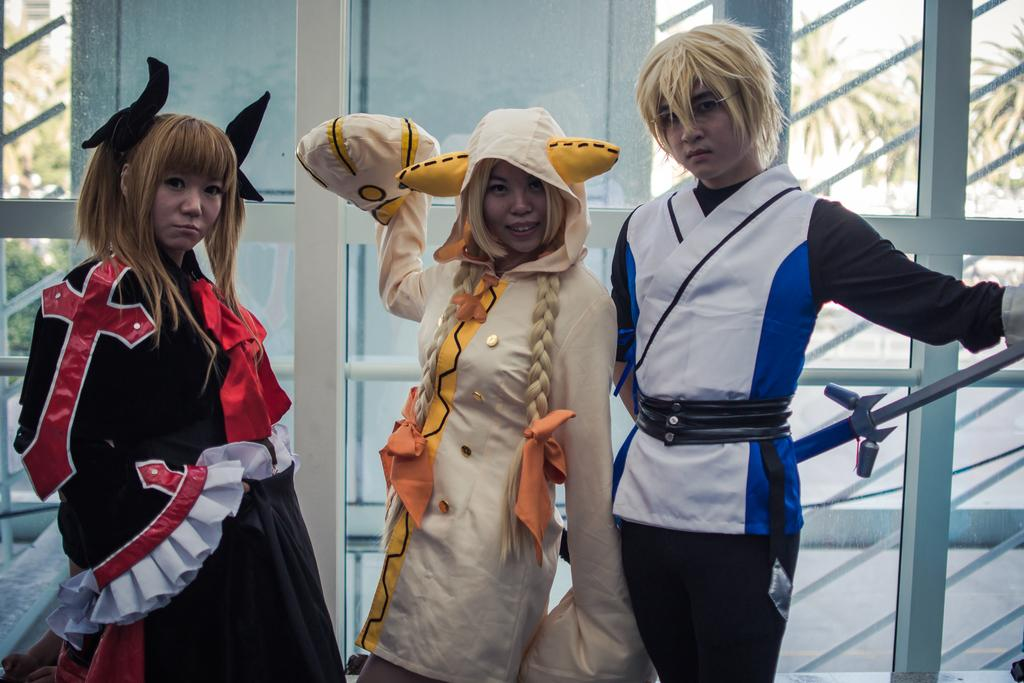How many people are in the image? There is a group of people in the image. What are the people wearing? The people are wearing costumes. What is the man holding in the image? The man is holding a metal rod. What can be seen in the background of the image? There are windows and plants visible in the background. What type of airplane can be seen flying in the image? There is no airplane visible in the image; it only features a group of people, some of whom are wearing costumes, and a man holding a metal rod. 